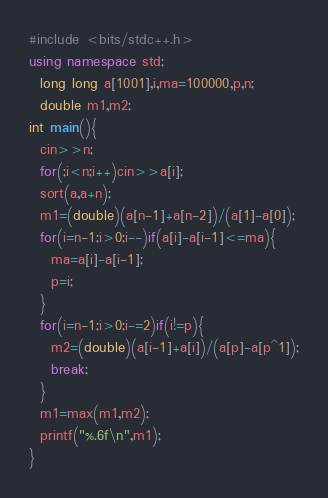Convert code to text. <code><loc_0><loc_0><loc_500><loc_500><_C++_>#include <bits/stdc++.h>
using namespace std;
  long long a[1001],i,ma=100000,p,n;
  double m1,m2;
int main(){
  cin>>n;
  for(;i<n;i++)cin>>a[i];
  sort(a,a+n);
  m1=(double)(a[n-1]+a[n-2])/(a[1]-a[0]);
  for(i=n-1;i>0;i--)if(a[i]-a[i-1]<=ma){
    ma=a[i]-a[i-1];
    p=i;
  }
  for(i=n-1;i>0;i-=2)if(i!=p){
    m2=(double)(a[i-1]+a[i])/(a[p]-a[p^1]);
    break;
  }
  m1=max(m1,m2);
  printf("%.6f\n",m1);
}</code> 